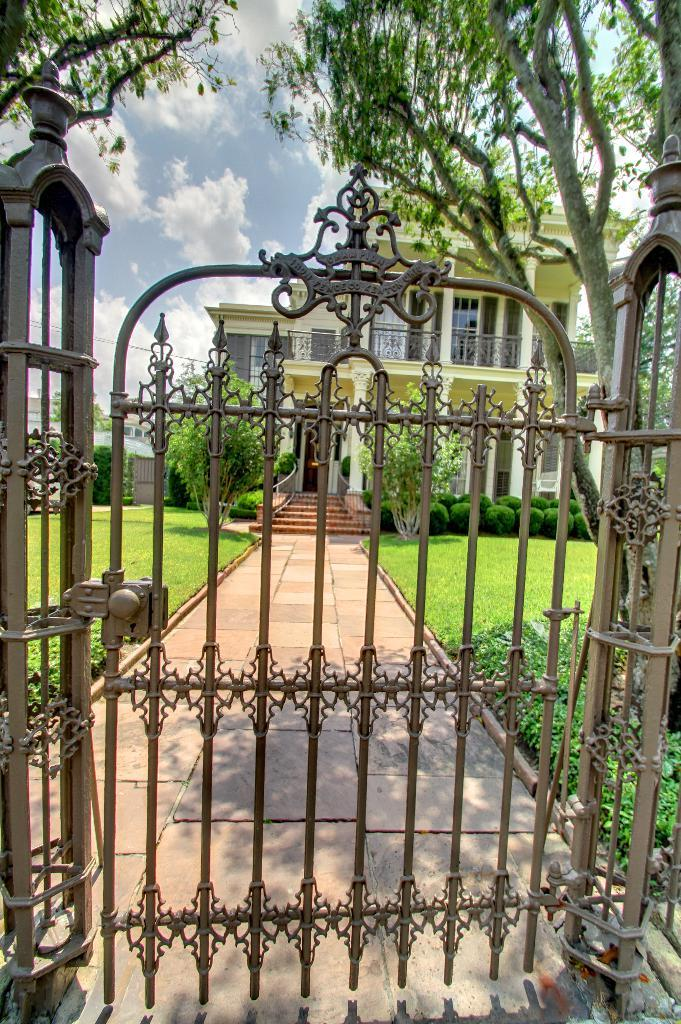What can be seen in the sky in the background of the image? There is a sky with clouds in the background of the image. What type of structure is visible in the background of the image? There is a building with pillars in the background of the image. What is the entrance feature in the image? There is a gate in the image. Are there any architectural elements near the building in the image? Yes, there are stairs near the building in the image. What type of vegetation is present in the image? There is grass, plants, and trees in the image. What type of wax can be seen melting on the tramp in the image? There is no tramp or wax present in the image. How does the brake system work on the trees in the image? There is no brake system present on the trees in the image; they are natural vegetation. 